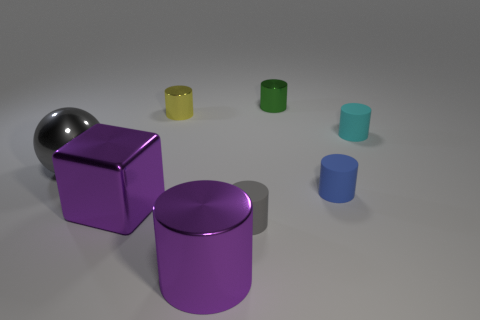Is the big metallic cylinder the same color as the large shiny cube?
Give a very brief answer. Yes. What number of objects are either small gray rubber cylinders or big things in front of the gray sphere?
Keep it short and to the point. 3. How many metal cylinders are behind the purple object that is in front of the tiny gray matte cylinder on the right side of the gray shiny ball?
Your answer should be compact. 2. There is a big cylinder that is the same color as the large block; what is it made of?
Provide a short and direct response. Metal. What number of large green balls are there?
Your answer should be compact. 0. Does the matte cylinder that is behind the metallic ball have the same size as the tiny blue rubber object?
Your response must be concise. Yes. How many metallic objects are cyan cylinders or cyan spheres?
Provide a short and direct response. 0. There is a gray object in front of the metal sphere; what number of big balls are in front of it?
Your response must be concise. 0. There is a metal thing that is both right of the yellow shiny cylinder and behind the small blue thing; what is its shape?
Give a very brief answer. Cylinder. What is the material of the cyan thing behind the metallic cylinder that is in front of the small matte object behind the large gray metal ball?
Provide a short and direct response. Rubber. 